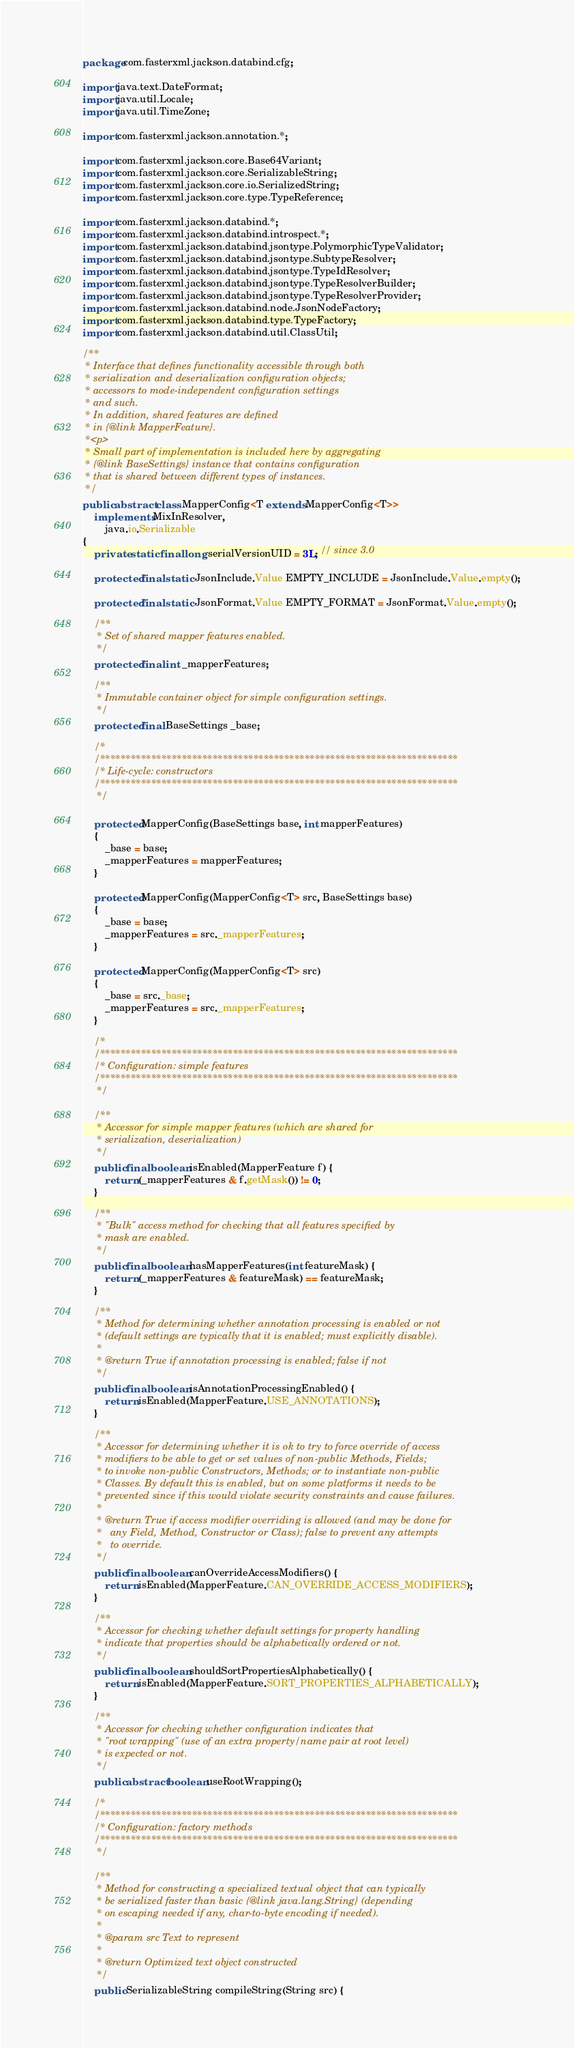Convert code to text. <code><loc_0><loc_0><loc_500><loc_500><_Java_>package com.fasterxml.jackson.databind.cfg;

import java.text.DateFormat;
import java.util.Locale;
import java.util.TimeZone;

import com.fasterxml.jackson.annotation.*;

import com.fasterxml.jackson.core.Base64Variant;
import com.fasterxml.jackson.core.SerializableString;
import com.fasterxml.jackson.core.io.SerializedString;
import com.fasterxml.jackson.core.type.TypeReference;

import com.fasterxml.jackson.databind.*;
import com.fasterxml.jackson.databind.introspect.*;
import com.fasterxml.jackson.databind.jsontype.PolymorphicTypeValidator;
import com.fasterxml.jackson.databind.jsontype.SubtypeResolver;
import com.fasterxml.jackson.databind.jsontype.TypeIdResolver;
import com.fasterxml.jackson.databind.jsontype.TypeResolverBuilder;
import com.fasterxml.jackson.databind.jsontype.TypeResolverProvider;
import com.fasterxml.jackson.databind.node.JsonNodeFactory;
import com.fasterxml.jackson.databind.type.TypeFactory;
import com.fasterxml.jackson.databind.util.ClassUtil;

/**
 * Interface that defines functionality accessible through both
 * serialization and deserialization configuration objects;
 * accessors to mode-independent configuration settings
 * and such.
 * In addition, shared features are defined
 * in {@link MapperFeature}.
 *<p>
 * Small part of implementation is included here by aggregating
 * {@link BaseSettings} instance that contains configuration
 * that is shared between different types of instances.
 */
public abstract class MapperConfig<T extends MapperConfig<T>>
    implements MixInResolver,
        java.io.Serializable
{
    private static final long serialVersionUID = 3L; // since 3.0

    protected final static JsonInclude.Value EMPTY_INCLUDE = JsonInclude.Value.empty();

    protected final static JsonFormat.Value EMPTY_FORMAT = JsonFormat.Value.empty();

    /**
     * Set of shared mapper features enabled.
     */
    protected final int _mapperFeatures;
    
    /**
     * Immutable container object for simple configuration settings.
     */
    protected final BaseSettings _base;

    /*
    /**********************************************************************
    /* Life-cycle: constructors
    /**********************************************************************
     */

    protected MapperConfig(BaseSettings base, int mapperFeatures)
    {
        _base = base;
        _mapperFeatures = mapperFeatures;
    }

    protected MapperConfig(MapperConfig<T> src, BaseSettings base)
    {
        _base = base;
        _mapperFeatures = src._mapperFeatures;
    }
    
    protected MapperConfig(MapperConfig<T> src)
    {
        _base = src._base;
        _mapperFeatures = src._mapperFeatures;
    }

    /*
    /**********************************************************************
    /* Configuration: simple features
    /**********************************************************************
     */

    /**
     * Accessor for simple mapper features (which are shared for
     * serialization, deserialization)
     */
    public final boolean isEnabled(MapperFeature f) {
        return (_mapperFeatures & f.getMask()) != 0;
    }

    /**
     * "Bulk" access method for checking that all features specified by
     * mask are enabled.
     */
    public final boolean hasMapperFeatures(int featureMask) {
        return (_mapperFeatures & featureMask) == featureMask;
    }
    
    /**
     * Method for determining whether annotation processing is enabled or not
     * (default settings are typically that it is enabled; must explicitly disable).
     * 
     * @return True if annotation processing is enabled; false if not
     */
    public final boolean isAnnotationProcessingEnabled() {
        return isEnabled(MapperFeature.USE_ANNOTATIONS);
    }

    /**
     * Accessor for determining whether it is ok to try to force override of access
     * modifiers to be able to get or set values of non-public Methods, Fields;
     * to invoke non-public Constructors, Methods; or to instantiate non-public
     * Classes. By default this is enabled, but on some platforms it needs to be
     * prevented since if this would violate security constraints and cause failures.
     * 
     * @return True if access modifier overriding is allowed (and may be done for
     *   any Field, Method, Constructor or Class); false to prevent any attempts
     *   to override.
     */
    public final boolean canOverrideAccessModifiers() {
        return isEnabled(MapperFeature.CAN_OVERRIDE_ACCESS_MODIFIERS);
    }

    /**
     * Accessor for checking whether default settings for property handling
     * indicate that properties should be alphabetically ordered or not.
     */
    public final boolean shouldSortPropertiesAlphabetically() {
        return isEnabled(MapperFeature.SORT_PROPERTIES_ALPHABETICALLY);
    }

    /**
     * Accessor for checking whether configuration indicates that
     * "root wrapping" (use of an extra property/name pair at root level)
     * is expected or not.
     */
    public abstract boolean useRootWrapping();

    /*
    /**********************************************************************
    /* Configuration: factory methods
    /**********************************************************************
     */

    /**
     * Method for constructing a specialized textual object that can typically
     * be serialized faster than basic {@link java.lang.String} (depending
     * on escaping needed if any, char-to-byte encoding if needed).
     * 
     * @param src Text to represent
     * 
     * @return Optimized text object constructed
     */
    public SerializableString compileString(String src) {</code> 